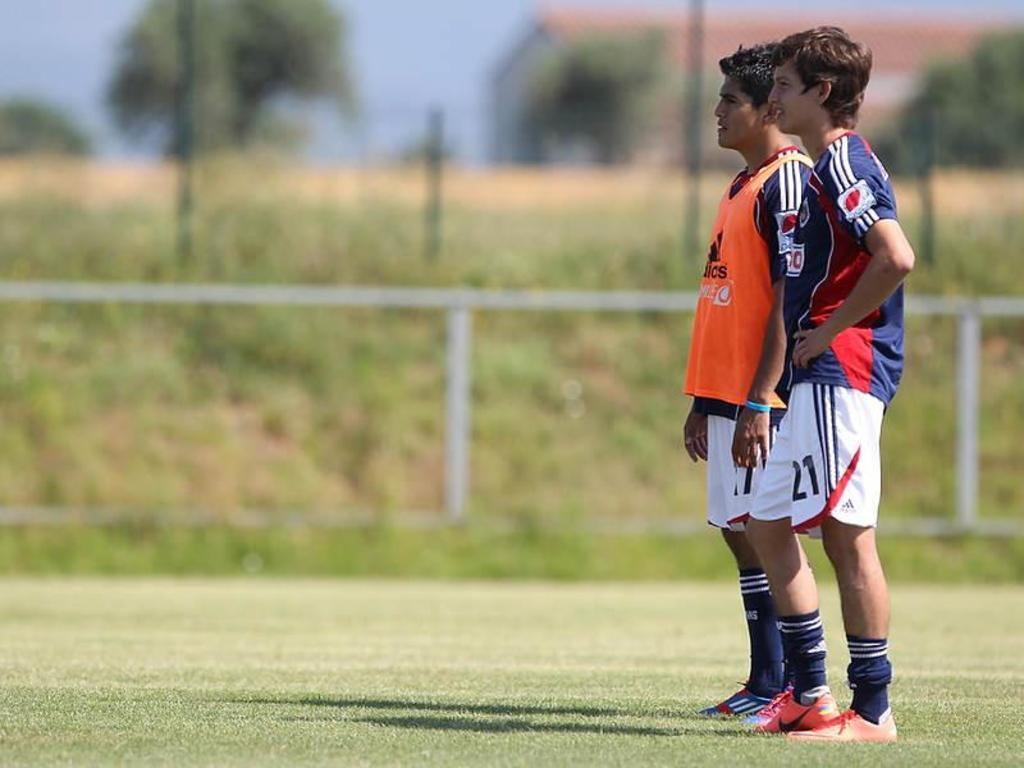How many people are in the image? There are two persons standing on the ground in the image. Can you describe the background of the image? The background is blurred, and there is a barrier, grass, poles, trees, a house, and the sky visible. What type of vegetation can be seen in the background? Trees can be seen in the background. What type of structure is visible in the background? There is a house in the background. What letters are visible on the van in the image? There is no van present in the image; it features a blurred background with a house, trees, and other elements. What type of tail can be seen on the animal in the image? There is no animal with a tail present in the image; it features two persons standing on the ground and a background with various elements. 